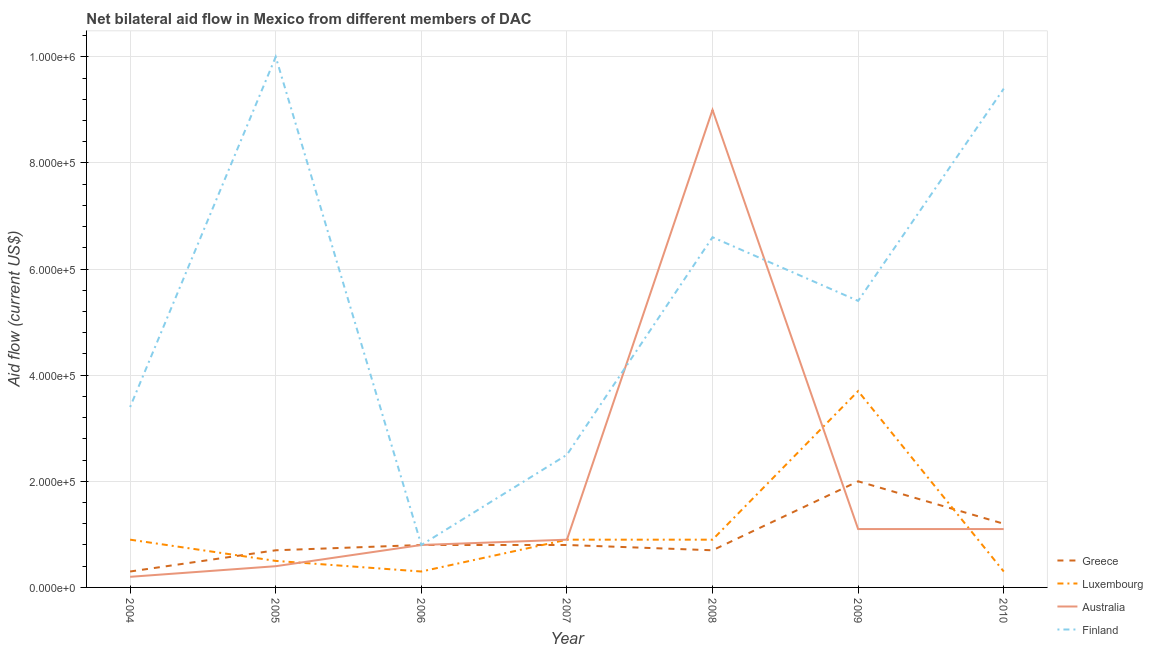How many different coloured lines are there?
Make the answer very short. 4. Is the number of lines equal to the number of legend labels?
Ensure brevity in your answer.  Yes. What is the amount of aid given by luxembourg in 2004?
Offer a terse response. 9.00e+04. Across all years, what is the maximum amount of aid given by greece?
Give a very brief answer. 2.00e+05. Across all years, what is the minimum amount of aid given by greece?
Provide a short and direct response. 3.00e+04. In which year was the amount of aid given by luxembourg minimum?
Make the answer very short. 2006. What is the total amount of aid given by greece in the graph?
Offer a terse response. 6.50e+05. What is the difference between the amount of aid given by finland in 2008 and that in 2010?
Your response must be concise. -2.80e+05. What is the difference between the amount of aid given by greece in 2007 and the amount of aid given by luxembourg in 2006?
Keep it short and to the point. 5.00e+04. What is the average amount of aid given by finland per year?
Offer a terse response. 5.44e+05. In the year 2009, what is the difference between the amount of aid given by luxembourg and amount of aid given by greece?
Give a very brief answer. 1.70e+05. In how many years, is the amount of aid given by luxembourg greater than 480000 US$?
Your answer should be compact. 0. What is the ratio of the amount of aid given by finland in 2008 to that in 2009?
Keep it short and to the point. 1.22. Is the amount of aid given by finland in 2004 less than that in 2009?
Offer a very short reply. Yes. What is the difference between the highest and the lowest amount of aid given by finland?
Offer a very short reply. 9.20e+05. In how many years, is the amount of aid given by finland greater than the average amount of aid given by finland taken over all years?
Ensure brevity in your answer.  3. Is the sum of the amount of aid given by luxembourg in 2008 and 2009 greater than the maximum amount of aid given by australia across all years?
Your answer should be very brief. No. Does the amount of aid given by finland monotonically increase over the years?
Provide a short and direct response. No. Is the amount of aid given by luxembourg strictly greater than the amount of aid given by finland over the years?
Ensure brevity in your answer.  No. What is the difference between two consecutive major ticks on the Y-axis?
Your answer should be compact. 2.00e+05. Are the values on the major ticks of Y-axis written in scientific E-notation?
Offer a very short reply. Yes. Does the graph contain any zero values?
Provide a short and direct response. No. Does the graph contain grids?
Provide a short and direct response. Yes. Where does the legend appear in the graph?
Ensure brevity in your answer.  Bottom right. How many legend labels are there?
Your response must be concise. 4. What is the title of the graph?
Give a very brief answer. Net bilateral aid flow in Mexico from different members of DAC. Does "Source data assessment" appear as one of the legend labels in the graph?
Keep it short and to the point. No. What is the Aid flow (current US$) of Greece in 2005?
Provide a short and direct response. 7.00e+04. What is the Aid flow (current US$) in Luxembourg in 2005?
Provide a short and direct response. 5.00e+04. What is the Aid flow (current US$) of Finland in 2005?
Offer a very short reply. 1.00e+06. What is the Aid flow (current US$) in Luxembourg in 2006?
Offer a terse response. 3.00e+04. What is the Aid flow (current US$) in Finland in 2006?
Provide a short and direct response. 8.00e+04. What is the Aid flow (current US$) in Greece in 2007?
Your answer should be compact. 8.00e+04. What is the Aid flow (current US$) of Luxembourg in 2007?
Keep it short and to the point. 9.00e+04. What is the Aid flow (current US$) in Greece in 2008?
Offer a terse response. 7.00e+04. What is the Aid flow (current US$) of Finland in 2008?
Your answer should be compact. 6.60e+05. What is the Aid flow (current US$) in Greece in 2009?
Your answer should be compact. 2.00e+05. What is the Aid flow (current US$) of Finland in 2009?
Give a very brief answer. 5.40e+05. What is the Aid flow (current US$) in Greece in 2010?
Keep it short and to the point. 1.20e+05. What is the Aid flow (current US$) of Luxembourg in 2010?
Keep it short and to the point. 3.00e+04. What is the Aid flow (current US$) of Finland in 2010?
Your response must be concise. 9.40e+05. Across all years, what is the maximum Aid flow (current US$) in Greece?
Make the answer very short. 2.00e+05. Across all years, what is the maximum Aid flow (current US$) in Finland?
Make the answer very short. 1.00e+06. Across all years, what is the minimum Aid flow (current US$) in Greece?
Provide a short and direct response. 3.00e+04. Across all years, what is the minimum Aid flow (current US$) in Luxembourg?
Offer a terse response. 3.00e+04. Across all years, what is the minimum Aid flow (current US$) in Australia?
Your answer should be very brief. 2.00e+04. What is the total Aid flow (current US$) in Greece in the graph?
Your answer should be compact. 6.50e+05. What is the total Aid flow (current US$) in Luxembourg in the graph?
Keep it short and to the point. 7.50e+05. What is the total Aid flow (current US$) of Australia in the graph?
Your answer should be compact. 1.35e+06. What is the total Aid flow (current US$) in Finland in the graph?
Offer a very short reply. 3.81e+06. What is the difference between the Aid flow (current US$) in Greece in 2004 and that in 2005?
Your answer should be compact. -4.00e+04. What is the difference between the Aid flow (current US$) of Australia in 2004 and that in 2005?
Make the answer very short. -2.00e+04. What is the difference between the Aid flow (current US$) of Finland in 2004 and that in 2005?
Offer a terse response. -6.60e+05. What is the difference between the Aid flow (current US$) in Luxembourg in 2004 and that in 2006?
Give a very brief answer. 6.00e+04. What is the difference between the Aid flow (current US$) of Australia in 2004 and that in 2006?
Give a very brief answer. -6.00e+04. What is the difference between the Aid flow (current US$) in Greece in 2004 and that in 2007?
Provide a short and direct response. -5.00e+04. What is the difference between the Aid flow (current US$) in Finland in 2004 and that in 2007?
Offer a terse response. 9.00e+04. What is the difference between the Aid flow (current US$) of Greece in 2004 and that in 2008?
Provide a short and direct response. -4.00e+04. What is the difference between the Aid flow (current US$) in Luxembourg in 2004 and that in 2008?
Ensure brevity in your answer.  0. What is the difference between the Aid flow (current US$) of Australia in 2004 and that in 2008?
Your answer should be very brief. -8.80e+05. What is the difference between the Aid flow (current US$) in Finland in 2004 and that in 2008?
Offer a very short reply. -3.20e+05. What is the difference between the Aid flow (current US$) of Luxembourg in 2004 and that in 2009?
Offer a very short reply. -2.80e+05. What is the difference between the Aid flow (current US$) in Finland in 2004 and that in 2009?
Offer a terse response. -2.00e+05. What is the difference between the Aid flow (current US$) of Luxembourg in 2004 and that in 2010?
Offer a terse response. 6.00e+04. What is the difference between the Aid flow (current US$) in Finland in 2004 and that in 2010?
Provide a succinct answer. -6.00e+05. What is the difference between the Aid flow (current US$) in Australia in 2005 and that in 2006?
Your response must be concise. -4.00e+04. What is the difference between the Aid flow (current US$) in Finland in 2005 and that in 2006?
Keep it short and to the point. 9.20e+05. What is the difference between the Aid flow (current US$) of Luxembourg in 2005 and that in 2007?
Your response must be concise. -4.00e+04. What is the difference between the Aid flow (current US$) in Finland in 2005 and that in 2007?
Your answer should be very brief. 7.50e+05. What is the difference between the Aid flow (current US$) in Greece in 2005 and that in 2008?
Keep it short and to the point. 0. What is the difference between the Aid flow (current US$) of Australia in 2005 and that in 2008?
Offer a terse response. -8.60e+05. What is the difference between the Aid flow (current US$) in Finland in 2005 and that in 2008?
Give a very brief answer. 3.40e+05. What is the difference between the Aid flow (current US$) in Luxembourg in 2005 and that in 2009?
Your answer should be very brief. -3.20e+05. What is the difference between the Aid flow (current US$) of Luxembourg in 2005 and that in 2010?
Give a very brief answer. 2.00e+04. What is the difference between the Aid flow (current US$) of Australia in 2005 and that in 2010?
Offer a terse response. -7.00e+04. What is the difference between the Aid flow (current US$) of Finland in 2005 and that in 2010?
Offer a very short reply. 6.00e+04. What is the difference between the Aid flow (current US$) of Luxembourg in 2006 and that in 2007?
Provide a succinct answer. -6.00e+04. What is the difference between the Aid flow (current US$) in Australia in 2006 and that in 2007?
Keep it short and to the point. -10000. What is the difference between the Aid flow (current US$) of Greece in 2006 and that in 2008?
Your answer should be very brief. 10000. What is the difference between the Aid flow (current US$) of Australia in 2006 and that in 2008?
Your response must be concise. -8.20e+05. What is the difference between the Aid flow (current US$) of Finland in 2006 and that in 2008?
Provide a short and direct response. -5.80e+05. What is the difference between the Aid flow (current US$) in Australia in 2006 and that in 2009?
Keep it short and to the point. -3.00e+04. What is the difference between the Aid flow (current US$) in Finland in 2006 and that in 2009?
Your response must be concise. -4.60e+05. What is the difference between the Aid flow (current US$) in Greece in 2006 and that in 2010?
Your answer should be very brief. -4.00e+04. What is the difference between the Aid flow (current US$) of Finland in 2006 and that in 2010?
Make the answer very short. -8.60e+05. What is the difference between the Aid flow (current US$) in Luxembourg in 2007 and that in 2008?
Offer a terse response. 0. What is the difference between the Aid flow (current US$) of Australia in 2007 and that in 2008?
Offer a very short reply. -8.10e+05. What is the difference between the Aid flow (current US$) in Finland in 2007 and that in 2008?
Provide a succinct answer. -4.10e+05. What is the difference between the Aid flow (current US$) in Luxembourg in 2007 and that in 2009?
Offer a terse response. -2.80e+05. What is the difference between the Aid flow (current US$) in Finland in 2007 and that in 2009?
Give a very brief answer. -2.90e+05. What is the difference between the Aid flow (current US$) in Greece in 2007 and that in 2010?
Your response must be concise. -4.00e+04. What is the difference between the Aid flow (current US$) of Australia in 2007 and that in 2010?
Ensure brevity in your answer.  -2.00e+04. What is the difference between the Aid flow (current US$) of Finland in 2007 and that in 2010?
Provide a short and direct response. -6.90e+05. What is the difference between the Aid flow (current US$) in Luxembourg in 2008 and that in 2009?
Your response must be concise. -2.80e+05. What is the difference between the Aid flow (current US$) of Australia in 2008 and that in 2009?
Your response must be concise. 7.90e+05. What is the difference between the Aid flow (current US$) of Finland in 2008 and that in 2009?
Offer a very short reply. 1.20e+05. What is the difference between the Aid flow (current US$) of Luxembourg in 2008 and that in 2010?
Offer a very short reply. 6.00e+04. What is the difference between the Aid flow (current US$) of Australia in 2008 and that in 2010?
Make the answer very short. 7.90e+05. What is the difference between the Aid flow (current US$) of Finland in 2008 and that in 2010?
Provide a succinct answer. -2.80e+05. What is the difference between the Aid flow (current US$) of Greece in 2009 and that in 2010?
Provide a succinct answer. 8.00e+04. What is the difference between the Aid flow (current US$) of Australia in 2009 and that in 2010?
Your response must be concise. 0. What is the difference between the Aid flow (current US$) of Finland in 2009 and that in 2010?
Provide a short and direct response. -4.00e+05. What is the difference between the Aid flow (current US$) in Greece in 2004 and the Aid flow (current US$) in Finland in 2005?
Provide a succinct answer. -9.70e+05. What is the difference between the Aid flow (current US$) in Luxembourg in 2004 and the Aid flow (current US$) in Finland in 2005?
Offer a terse response. -9.10e+05. What is the difference between the Aid flow (current US$) of Australia in 2004 and the Aid flow (current US$) of Finland in 2005?
Offer a very short reply. -9.80e+05. What is the difference between the Aid flow (current US$) in Greece in 2004 and the Aid flow (current US$) in Luxembourg in 2006?
Your answer should be very brief. 0. What is the difference between the Aid flow (current US$) in Greece in 2004 and the Aid flow (current US$) in Australia in 2006?
Your answer should be very brief. -5.00e+04. What is the difference between the Aid flow (current US$) in Greece in 2004 and the Aid flow (current US$) in Luxembourg in 2007?
Offer a very short reply. -6.00e+04. What is the difference between the Aid flow (current US$) in Greece in 2004 and the Aid flow (current US$) in Australia in 2007?
Offer a very short reply. -6.00e+04. What is the difference between the Aid flow (current US$) of Greece in 2004 and the Aid flow (current US$) of Finland in 2007?
Your answer should be very brief. -2.20e+05. What is the difference between the Aid flow (current US$) in Luxembourg in 2004 and the Aid flow (current US$) in Finland in 2007?
Ensure brevity in your answer.  -1.60e+05. What is the difference between the Aid flow (current US$) in Greece in 2004 and the Aid flow (current US$) in Australia in 2008?
Make the answer very short. -8.70e+05. What is the difference between the Aid flow (current US$) in Greece in 2004 and the Aid flow (current US$) in Finland in 2008?
Provide a succinct answer. -6.30e+05. What is the difference between the Aid flow (current US$) of Luxembourg in 2004 and the Aid flow (current US$) of Australia in 2008?
Offer a very short reply. -8.10e+05. What is the difference between the Aid flow (current US$) in Luxembourg in 2004 and the Aid flow (current US$) in Finland in 2008?
Your response must be concise. -5.70e+05. What is the difference between the Aid flow (current US$) of Australia in 2004 and the Aid flow (current US$) of Finland in 2008?
Provide a succinct answer. -6.40e+05. What is the difference between the Aid flow (current US$) in Greece in 2004 and the Aid flow (current US$) in Luxembourg in 2009?
Offer a terse response. -3.40e+05. What is the difference between the Aid flow (current US$) of Greece in 2004 and the Aid flow (current US$) of Australia in 2009?
Make the answer very short. -8.00e+04. What is the difference between the Aid flow (current US$) in Greece in 2004 and the Aid flow (current US$) in Finland in 2009?
Offer a very short reply. -5.10e+05. What is the difference between the Aid flow (current US$) in Luxembourg in 2004 and the Aid flow (current US$) in Australia in 2009?
Your response must be concise. -2.00e+04. What is the difference between the Aid flow (current US$) in Luxembourg in 2004 and the Aid flow (current US$) in Finland in 2009?
Your response must be concise. -4.50e+05. What is the difference between the Aid flow (current US$) in Australia in 2004 and the Aid flow (current US$) in Finland in 2009?
Keep it short and to the point. -5.20e+05. What is the difference between the Aid flow (current US$) in Greece in 2004 and the Aid flow (current US$) in Luxembourg in 2010?
Ensure brevity in your answer.  0. What is the difference between the Aid flow (current US$) of Greece in 2004 and the Aid flow (current US$) of Australia in 2010?
Offer a terse response. -8.00e+04. What is the difference between the Aid flow (current US$) of Greece in 2004 and the Aid flow (current US$) of Finland in 2010?
Offer a terse response. -9.10e+05. What is the difference between the Aid flow (current US$) in Luxembourg in 2004 and the Aid flow (current US$) in Finland in 2010?
Give a very brief answer. -8.50e+05. What is the difference between the Aid flow (current US$) of Australia in 2004 and the Aid flow (current US$) of Finland in 2010?
Provide a succinct answer. -9.20e+05. What is the difference between the Aid flow (current US$) in Greece in 2005 and the Aid flow (current US$) in Finland in 2006?
Provide a short and direct response. -10000. What is the difference between the Aid flow (current US$) of Luxembourg in 2005 and the Aid flow (current US$) of Australia in 2006?
Give a very brief answer. -3.00e+04. What is the difference between the Aid flow (current US$) in Luxembourg in 2005 and the Aid flow (current US$) in Finland in 2006?
Keep it short and to the point. -3.00e+04. What is the difference between the Aid flow (current US$) in Greece in 2005 and the Aid flow (current US$) in Australia in 2007?
Keep it short and to the point. -2.00e+04. What is the difference between the Aid flow (current US$) of Luxembourg in 2005 and the Aid flow (current US$) of Australia in 2007?
Offer a very short reply. -4.00e+04. What is the difference between the Aid flow (current US$) in Australia in 2005 and the Aid flow (current US$) in Finland in 2007?
Your answer should be compact. -2.10e+05. What is the difference between the Aid flow (current US$) of Greece in 2005 and the Aid flow (current US$) of Australia in 2008?
Offer a terse response. -8.30e+05. What is the difference between the Aid flow (current US$) in Greece in 2005 and the Aid flow (current US$) in Finland in 2008?
Give a very brief answer. -5.90e+05. What is the difference between the Aid flow (current US$) in Luxembourg in 2005 and the Aid flow (current US$) in Australia in 2008?
Your answer should be compact. -8.50e+05. What is the difference between the Aid flow (current US$) of Luxembourg in 2005 and the Aid flow (current US$) of Finland in 2008?
Make the answer very short. -6.10e+05. What is the difference between the Aid flow (current US$) of Australia in 2005 and the Aid flow (current US$) of Finland in 2008?
Give a very brief answer. -6.20e+05. What is the difference between the Aid flow (current US$) of Greece in 2005 and the Aid flow (current US$) of Luxembourg in 2009?
Your answer should be compact. -3.00e+05. What is the difference between the Aid flow (current US$) in Greece in 2005 and the Aid flow (current US$) in Australia in 2009?
Provide a short and direct response. -4.00e+04. What is the difference between the Aid flow (current US$) of Greece in 2005 and the Aid flow (current US$) of Finland in 2009?
Your answer should be very brief. -4.70e+05. What is the difference between the Aid flow (current US$) in Luxembourg in 2005 and the Aid flow (current US$) in Australia in 2009?
Make the answer very short. -6.00e+04. What is the difference between the Aid flow (current US$) in Luxembourg in 2005 and the Aid flow (current US$) in Finland in 2009?
Your answer should be compact. -4.90e+05. What is the difference between the Aid flow (current US$) of Australia in 2005 and the Aid flow (current US$) of Finland in 2009?
Make the answer very short. -5.00e+05. What is the difference between the Aid flow (current US$) in Greece in 2005 and the Aid flow (current US$) in Australia in 2010?
Ensure brevity in your answer.  -4.00e+04. What is the difference between the Aid flow (current US$) in Greece in 2005 and the Aid flow (current US$) in Finland in 2010?
Provide a short and direct response. -8.70e+05. What is the difference between the Aid flow (current US$) in Luxembourg in 2005 and the Aid flow (current US$) in Finland in 2010?
Provide a short and direct response. -8.90e+05. What is the difference between the Aid flow (current US$) in Australia in 2005 and the Aid flow (current US$) in Finland in 2010?
Offer a terse response. -9.00e+05. What is the difference between the Aid flow (current US$) of Greece in 2006 and the Aid flow (current US$) of Australia in 2007?
Keep it short and to the point. -10000. What is the difference between the Aid flow (current US$) of Greece in 2006 and the Aid flow (current US$) of Australia in 2008?
Ensure brevity in your answer.  -8.20e+05. What is the difference between the Aid flow (current US$) of Greece in 2006 and the Aid flow (current US$) of Finland in 2008?
Provide a succinct answer. -5.80e+05. What is the difference between the Aid flow (current US$) of Luxembourg in 2006 and the Aid flow (current US$) of Australia in 2008?
Keep it short and to the point. -8.70e+05. What is the difference between the Aid flow (current US$) in Luxembourg in 2006 and the Aid flow (current US$) in Finland in 2008?
Make the answer very short. -6.30e+05. What is the difference between the Aid flow (current US$) of Australia in 2006 and the Aid flow (current US$) of Finland in 2008?
Offer a terse response. -5.80e+05. What is the difference between the Aid flow (current US$) in Greece in 2006 and the Aid flow (current US$) in Luxembourg in 2009?
Your answer should be compact. -2.90e+05. What is the difference between the Aid flow (current US$) of Greece in 2006 and the Aid flow (current US$) of Australia in 2009?
Provide a short and direct response. -3.00e+04. What is the difference between the Aid flow (current US$) in Greece in 2006 and the Aid flow (current US$) in Finland in 2009?
Your response must be concise. -4.60e+05. What is the difference between the Aid flow (current US$) of Luxembourg in 2006 and the Aid flow (current US$) of Australia in 2009?
Provide a succinct answer. -8.00e+04. What is the difference between the Aid flow (current US$) in Luxembourg in 2006 and the Aid flow (current US$) in Finland in 2009?
Give a very brief answer. -5.10e+05. What is the difference between the Aid flow (current US$) of Australia in 2006 and the Aid flow (current US$) of Finland in 2009?
Offer a terse response. -4.60e+05. What is the difference between the Aid flow (current US$) of Greece in 2006 and the Aid flow (current US$) of Australia in 2010?
Offer a very short reply. -3.00e+04. What is the difference between the Aid flow (current US$) of Greece in 2006 and the Aid flow (current US$) of Finland in 2010?
Ensure brevity in your answer.  -8.60e+05. What is the difference between the Aid flow (current US$) of Luxembourg in 2006 and the Aid flow (current US$) of Finland in 2010?
Provide a short and direct response. -9.10e+05. What is the difference between the Aid flow (current US$) in Australia in 2006 and the Aid flow (current US$) in Finland in 2010?
Offer a terse response. -8.60e+05. What is the difference between the Aid flow (current US$) in Greece in 2007 and the Aid flow (current US$) in Australia in 2008?
Keep it short and to the point. -8.20e+05. What is the difference between the Aid flow (current US$) of Greece in 2007 and the Aid flow (current US$) of Finland in 2008?
Keep it short and to the point. -5.80e+05. What is the difference between the Aid flow (current US$) in Luxembourg in 2007 and the Aid flow (current US$) in Australia in 2008?
Provide a short and direct response. -8.10e+05. What is the difference between the Aid flow (current US$) in Luxembourg in 2007 and the Aid flow (current US$) in Finland in 2008?
Provide a short and direct response. -5.70e+05. What is the difference between the Aid flow (current US$) of Australia in 2007 and the Aid flow (current US$) of Finland in 2008?
Offer a very short reply. -5.70e+05. What is the difference between the Aid flow (current US$) in Greece in 2007 and the Aid flow (current US$) in Luxembourg in 2009?
Make the answer very short. -2.90e+05. What is the difference between the Aid flow (current US$) of Greece in 2007 and the Aid flow (current US$) of Australia in 2009?
Offer a terse response. -3.00e+04. What is the difference between the Aid flow (current US$) in Greece in 2007 and the Aid flow (current US$) in Finland in 2009?
Give a very brief answer. -4.60e+05. What is the difference between the Aid flow (current US$) of Luxembourg in 2007 and the Aid flow (current US$) of Australia in 2009?
Give a very brief answer. -2.00e+04. What is the difference between the Aid flow (current US$) of Luxembourg in 2007 and the Aid flow (current US$) of Finland in 2009?
Provide a short and direct response. -4.50e+05. What is the difference between the Aid flow (current US$) of Australia in 2007 and the Aid flow (current US$) of Finland in 2009?
Keep it short and to the point. -4.50e+05. What is the difference between the Aid flow (current US$) in Greece in 2007 and the Aid flow (current US$) in Luxembourg in 2010?
Keep it short and to the point. 5.00e+04. What is the difference between the Aid flow (current US$) of Greece in 2007 and the Aid flow (current US$) of Finland in 2010?
Your answer should be very brief. -8.60e+05. What is the difference between the Aid flow (current US$) in Luxembourg in 2007 and the Aid flow (current US$) in Australia in 2010?
Offer a terse response. -2.00e+04. What is the difference between the Aid flow (current US$) in Luxembourg in 2007 and the Aid flow (current US$) in Finland in 2010?
Your answer should be compact. -8.50e+05. What is the difference between the Aid flow (current US$) of Australia in 2007 and the Aid flow (current US$) of Finland in 2010?
Your response must be concise. -8.50e+05. What is the difference between the Aid flow (current US$) in Greece in 2008 and the Aid flow (current US$) in Finland in 2009?
Your answer should be compact. -4.70e+05. What is the difference between the Aid flow (current US$) of Luxembourg in 2008 and the Aid flow (current US$) of Australia in 2009?
Make the answer very short. -2.00e+04. What is the difference between the Aid flow (current US$) in Luxembourg in 2008 and the Aid flow (current US$) in Finland in 2009?
Offer a very short reply. -4.50e+05. What is the difference between the Aid flow (current US$) in Greece in 2008 and the Aid flow (current US$) in Luxembourg in 2010?
Provide a succinct answer. 4.00e+04. What is the difference between the Aid flow (current US$) of Greece in 2008 and the Aid flow (current US$) of Australia in 2010?
Give a very brief answer. -4.00e+04. What is the difference between the Aid flow (current US$) in Greece in 2008 and the Aid flow (current US$) in Finland in 2010?
Provide a succinct answer. -8.70e+05. What is the difference between the Aid flow (current US$) in Luxembourg in 2008 and the Aid flow (current US$) in Finland in 2010?
Offer a terse response. -8.50e+05. What is the difference between the Aid flow (current US$) of Greece in 2009 and the Aid flow (current US$) of Luxembourg in 2010?
Give a very brief answer. 1.70e+05. What is the difference between the Aid flow (current US$) of Greece in 2009 and the Aid flow (current US$) of Australia in 2010?
Offer a terse response. 9.00e+04. What is the difference between the Aid flow (current US$) of Greece in 2009 and the Aid flow (current US$) of Finland in 2010?
Your answer should be very brief. -7.40e+05. What is the difference between the Aid flow (current US$) in Luxembourg in 2009 and the Aid flow (current US$) in Finland in 2010?
Ensure brevity in your answer.  -5.70e+05. What is the difference between the Aid flow (current US$) of Australia in 2009 and the Aid flow (current US$) of Finland in 2010?
Give a very brief answer. -8.30e+05. What is the average Aid flow (current US$) in Greece per year?
Offer a very short reply. 9.29e+04. What is the average Aid flow (current US$) in Luxembourg per year?
Provide a short and direct response. 1.07e+05. What is the average Aid flow (current US$) of Australia per year?
Your response must be concise. 1.93e+05. What is the average Aid flow (current US$) in Finland per year?
Provide a succinct answer. 5.44e+05. In the year 2004, what is the difference between the Aid flow (current US$) of Greece and Aid flow (current US$) of Finland?
Provide a succinct answer. -3.10e+05. In the year 2004, what is the difference between the Aid flow (current US$) in Luxembourg and Aid flow (current US$) in Australia?
Your answer should be very brief. 7.00e+04. In the year 2004, what is the difference between the Aid flow (current US$) of Australia and Aid flow (current US$) of Finland?
Provide a short and direct response. -3.20e+05. In the year 2005, what is the difference between the Aid flow (current US$) in Greece and Aid flow (current US$) in Luxembourg?
Your answer should be compact. 2.00e+04. In the year 2005, what is the difference between the Aid flow (current US$) in Greece and Aid flow (current US$) in Australia?
Your answer should be compact. 3.00e+04. In the year 2005, what is the difference between the Aid flow (current US$) in Greece and Aid flow (current US$) in Finland?
Keep it short and to the point. -9.30e+05. In the year 2005, what is the difference between the Aid flow (current US$) of Luxembourg and Aid flow (current US$) of Australia?
Offer a terse response. 10000. In the year 2005, what is the difference between the Aid flow (current US$) in Luxembourg and Aid flow (current US$) in Finland?
Keep it short and to the point. -9.50e+05. In the year 2005, what is the difference between the Aid flow (current US$) in Australia and Aid flow (current US$) in Finland?
Offer a very short reply. -9.60e+05. In the year 2006, what is the difference between the Aid flow (current US$) of Greece and Aid flow (current US$) of Luxembourg?
Your answer should be compact. 5.00e+04. In the year 2006, what is the difference between the Aid flow (current US$) in Luxembourg and Aid flow (current US$) in Finland?
Provide a succinct answer. -5.00e+04. In the year 2007, what is the difference between the Aid flow (current US$) in Greece and Aid flow (current US$) in Australia?
Ensure brevity in your answer.  -10000. In the year 2007, what is the difference between the Aid flow (current US$) of Greece and Aid flow (current US$) of Finland?
Offer a very short reply. -1.70e+05. In the year 2007, what is the difference between the Aid flow (current US$) in Luxembourg and Aid flow (current US$) in Finland?
Offer a terse response. -1.60e+05. In the year 2008, what is the difference between the Aid flow (current US$) in Greece and Aid flow (current US$) in Luxembourg?
Your answer should be compact. -2.00e+04. In the year 2008, what is the difference between the Aid flow (current US$) in Greece and Aid flow (current US$) in Australia?
Your response must be concise. -8.30e+05. In the year 2008, what is the difference between the Aid flow (current US$) of Greece and Aid flow (current US$) of Finland?
Offer a very short reply. -5.90e+05. In the year 2008, what is the difference between the Aid flow (current US$) in Luxembourg and Aid flow (current US$) in Australia?
Provide a succinct answer. -8.10e+05. In the year 2008, what is the difference between the Aid flow (current US$) in Luxembourg and Aid flow (current US$) in Finland?
Ensure brevity in your answer.  -5.70e+05. In the year 2009, what is the difference between the Aid flow (current US$) in Luxembourg and Aid flow (current US$) in Australia?
Provide a short and direct response. 2.60e+05. In the year 2009, what is the difference between the Aid flow (current US$) of Luxembourg and Aid flow (current US$) of Finland?
Your answer should be very brief. -1.70e+05. In the year 2009, what is the difference between the Aid flow (current US$) of Australia and Aid flow (current US$) of Finland?
Your response must be concise. -4.30e+05. In the year 2010, what is the difference between the Aid flow (current US$) in Greece and Aid flow (current US$) in Luxembourg?
Offer a very short reply. 9.00e+04. In the year 2010, what is the difference between the Aid flow (current US$) in Greece and Aid flow (current US$) in Australia?
Make the answer very short. 10000. In the year 2010, what is the difference between the Aid flow (current US$) of Greece and Aid flow (current US$) of Finland?
Offer a terse response. -8.20e+05. In the year 2010, what is the difference between the Aid flow (current US$) of Luxembourg and Aid flow (current US$) of Finland?
Ensure brevity in your answer.  -9.10e+05. In the year 2010, what is the difference between the Aid flow (current US$) in Australia and Aid flow (current US$) in Finland?
Provide a succinct answer. -8.30e+05. What is the ratio of the Aid flow (current US$) in Greece in 2004 to that in 2005?
Your answer should be compact. 0.43. What is the ratio of the Aid flow (current US$) of Luxembourg in 2004 to that in 2005?
Make the answer very short. 1.8. What is the ratio of the Aid flow (current US$) of Finland in 2004 to that in 2005?
Provide a short and direct response. 0.34. What is the ratio of the Aid flow (current US$) of Greece in 2004 to that in 2006?
Keep it short and to the point. 0.38. What is the ratio of the Aid flow (current US$) of Australia in 2004 to that in 2006?
Your answer should be compact. 0.25. What is the ratio of the Aid flow (current US$) of Finland in 2004 to that in 2006?
Make the answer very short. 4.25. What is the ratio of the Aid flow (current US$) in Luxembourg in 2004 to that in 2007?
Provide a short and direct response. 1. What is the ratio of the Aid flow (current US$) of Australia in 2004 to that in 2007?
Provide a short and direct response. 0.22. What is the ratio of the Aid flow (current US$) of Finland in 2004 to that in 2007?
Offer a terse response. 1.36. What is the ratio of the Aid flow (current US$) in Greece in 2004 to that in 2008?
Your answer should be very brief. 0.43. What is the ratio of the Aid flow (current US$) of Australia in 2004 to that in 2008?
Your response must be concise. 0.02. What is the ratio of the Aid flow (current US$) in Finland in 2004 to that in 2008?
Offer a terse response. 0.52. What is the ratio of the Aid flow (current US$) in Luxembourg in 2004 to that in 2009?
Your response must be concise. 0.24. What is the ratio of the Aid flow (current US$) of Australia in 2004 to that in 2009?
Offer a terse response. 0.18. What is the ratio of the Aid flow (current US$) in Finland in 2004 to that in 2009?
Keep it short and to the point. 0.63. What is the ratio of the Aid flow (current US$) of Australia in 2004 to that in 2010?
Provide a short and direct response. 0.18. What is the ratio of the Aid flow (current US$) in Finland in 2004 to that in 2010?
Your response must be concise. 0.36. What is the ratio of the Aid flow (current US$) of Greece in 2005 to that in 2006?
Keep it short and to the point. 0.88. What is the ratio of the Aid flow (current US$) in Australia in 2005 to that in 2006?
Your response must be concise. 0.5. What is the ratio of the Aid flow (current US$) in Greece in 2005 to that in 2007?
Give a very brief answer. 0.88. What is the ratio of the Aid flow (current US$) in Luxembourg in 2005 to that in 2007?
Provide a short and direct response. 0.56. What is the ratio of the Aid flow (current US$) in Australia in 2005 to that in 2007?
Offer a very short reply. 0.44. What is the ratio of the Aid flow (current US$) of Finland in 2005 to that in 2007?
Provide a succinct answer. 4. What is the ratio of the Aid flow (current US$) of Greece in 2005 to that in 2008?
Make the answer very short. 1. What is the ratio of the Aid flow (current US$) in Luxembourg in 2005 to that in 2008?
Offer a terse response. 0.56. What is the ratio of the Aid flow (current US$) in Australia in 2005 to that in 2008?
Offer a very short reply. 0.04. What is the ratio of the Aid flow (current US$) of Finland in 2005 to that in 2008?
Keep it short and to the point. 1.52. What is the ratio of the Aid flow (current US$) of Greece in 2005 to that in 2009?
Provide a succinct answer. 0.35. What is the ratio of the Aid flow (current US$) of Luxembourg in 2005 to that in 2009?
Provide a succinct answer. 0.14. What is the ratio of the Aid flow (current US$) in Australia in 2005 to that in 2009?
Offer a very short reply. 0.36. What is the ratio of the Aid flow (current US$) in Finland in 2005 to that in 2009?
Provide a succinct answer. 1.85. What is the ratio of the Aid flow (current US$) in Greece in 2005 to that in 2010?
Ensure brevity in your answer.  0.58. What is the ratio of the Aid flow (current US$) of Australia in 2005 to that in 2010?
Your response must be concise. 0.36. What is the ratio of the Aid flow (current US$) of Finland in 2005 to that in 2010?
Provide a short and direct response. 1.06. What is the ratio of the Aid flow (current US$) of Greece in 2006 to that in 2007?
Ensure brevity in your answer.  1. What is the ratio of the Aid flow (current US$) in Luxembourg in 2006 to that in 2007?
Keep it short and to the point. 0.33. What is the ratio of the Aid flow (current US$) of Australia in 2006 to that in 2007?
Offer a terse response. 0.89. What is the ratio of the Aid flow (current US$) in Finland in 2006 to that in 2007?
Your response must be concise. 0.32. What is the ratio of the Aid flow (current US$) of Greece in 2006 to that in 2008?
Offer a very short reply. 1.14. What is the ratio of the Aid flow (current US$) in Luxembourg in 2006 to that in 2008?
Offer a terse response. 0.33. What is the ratio of the Aid flow (current US$) in Australia in 2006 to that in 2008?
Offer a terse response. 0.09. What is the ratio of the Aid flow (current US$) of Finland in 2006 to that in 2008?
Your answer should be compact. 0.12. What is the ratio of the Aid flow (current US$) in Greece in 2006 to that in 2009?
Provide a succinct answer. 0.4. What is the ratio of the Aid flow (current US$) in Luxembourg in 2006 to that in 2009?
Your answer should be very brief. 0.08. What is the ratio of the Aid flow (current US$) in Australia in 2006 to that in 2009?
Ensure brevity in your answer.  0.73. What is the ratio of the Aid flow (current US$) of Finland in 2006 to that in 2009?
Make the answer very short. 0.15. What is the ratio of the Aid flow (current US$) of Greece in 2006 to that in 2010?
Make the answer very short. 0.67. What is the ratio of the Aid flow (current US$) of Luxembourg in 2006 to that in 2010?
Provide a short and direct response. 1. What is the ratio of the Aid flow (current US$) in Australia in 2006 to that in 2010?
Keep it short and to the point. 0.73. What is the ratio of the Aid flow (current US$) in Finland in 2006 to that in 2010?
Make the answer very short. 0.09. What is the ratio of the Aid flow (current US$) in Greece in 2007 to that in 2008?
Give a very brief answer. 1.14. What is the ratio of the Aid flow (current US$) in Luxembourg in 2007 to that in 2008?
Offer a terse response. 1. What is the ratio of the Aid flow (current US$) of Finland in 2007 to that in 2008?
Provide a succinct answer. 0.38. What is the ratio of the Aid flow (current US$) of Greece in 2007 to that in 2009?
Your answer should be very brief. 0.4. What is the ratio of the Aid flow (current US$) of Luxembourg in 2007 to that in 2009?
Provide a short and direct response. 0.24. What is the ratio of the Aid flow (current US$) in Australia in 2007 to that in 2009?
Make the answer very short. 0.82. What is the ratio of the Aid flow (current US$) in Finland in 2007 to that in 2009?
Provide a succinct answer. 0.46. What is the ratio of the Aid flow (current US$) of Greece in 2007 to that in 2010?
Keep it short and to the point. 0.67. What is the ratio of the Aid flow (current US$) in Luxembourg in 2007 to that in 2010?
Keep it short and to the point. 3. What is the ratio of the Aid flow (current US$) of Australia in 2007 to that in 2010?
Offer a terse response. 0.82. What is the ratio of the Aid flow (current US$) of Finland in 2007 to that in 2010?
Make the answer very short. 0.27. What is the ratio of the Aid flow (current US$) of Greece in 2008 to that in 2009?
Your answer should be compact. 0.35. What is the ratio of the Aid flow (current US$) in Luxembourg in 2008 to that in 2009?
Your response must be concise. 0.24. What is the ratio of the Aid flow (current US$) of Australia in 2008 to that in 2009?
Your response must be concise. 8.18. What is the ratio of the Aid flow (current US$) of Finland in 2008 to that in 2009?
Provide a succinct answer. 1.22. What is the ratio of the Aid flow (current US$) of Greece in 2008 to that in 2010?
Ensure brevity in your answer.  0.58. What is the ratio of the Aid flow (current US$) of Luxembourg in 2008 to that in 2010?
Your answer should be very brief. 3. What is the ratio of the Aid flow (current US$) in Australia in 2008 to that in 2010?
Your response must be concise. 8.18. What is the ratio of the Aid flow (current US$) in Finland in 2008 to that in 2010?
Make the answer very short. 0.7. What is the ratio of the Aid flow (current US$) of Luxembourg in 2009 to that in 2010?
Your response must be concise. 12.33. What is the ratio of the Aid flow (current US$) of Finland in 2009 to that in 2010?
Keep it short and to the point. 0.57. What is the difference between the highest and the second highest Aid flow (current US$) of Greece?
Provide a succinct answer. 8.00e+04. What is the difference between the highest and the second highest Aid flow (current US$) in Luxembourg?
Make the answer very short. 2.80e+05. What is the difference between the highest and the second highest Aid flow (current US$) of Australia?
Give a very brief answer. 7.90e+05. What is the difference between the highest and the second highest Aid flow (current US$) of Finland?
Your response must be concise. 6.00e+04. What is the difference between the highest and the lowest Aid flow (current US$) in Luxembourg?
Keep it short and to the point. 3.40e+05. What is the difference between the highest and the lowest Aid flow (current US$) in Australia?
Offer a very short reply. 8.80e+05. What is the difference between the highest and the lowest Aid flow (current US$) of Finland?
Offer a very short reply. 9.20e+05. 